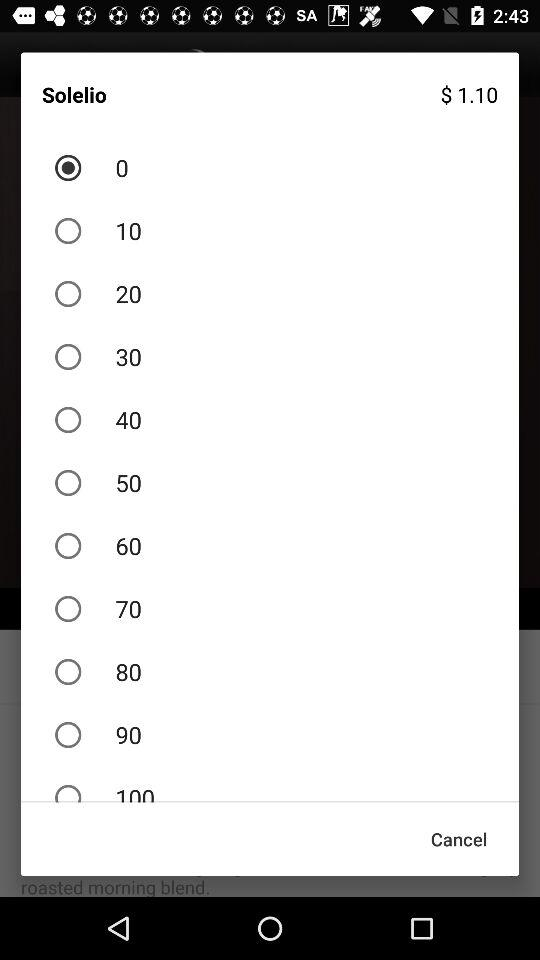What is the price of the "Solelio"? The price is $1.10. 